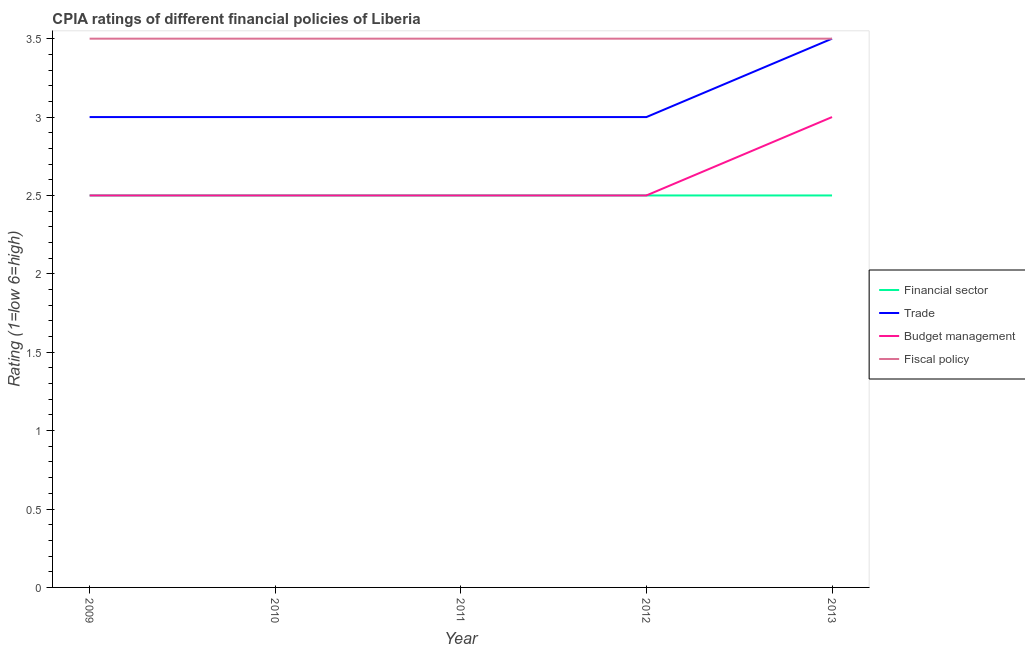What is the cpia rating of fiscal policy in 2011?
Make the answer very short. 3.5. In which year was the cpia rating of fiscal policy maximum?
Your answer should be very brief. 2009. In which year was the cpia rating of fiscal policy minimum?
Your answer should be compact. 2009. What is the difference between the cpia rating of fiscal policy in 2010 and that in 2013?
Your answer should be compact. 0. What is the difference between the cpia rating of financial sector in 2011 and the cpia rating of fiscal policy in 2012?
Give a very brief answer. -1. What is the average cpia rating of budget management per year?
Make the answer very short. 2.6. In the year 2009, what is the difference between the cpia rating of budget management and cpia rating of financial sector?
Ensure brevity in your answer.  0. What is the difference between the highest and the lowest cpia rating of fiscal policy?
Make the answer very short. 0. Is it the case that in every year, the sum of the cpia rating of trade and cpia rating of budget management is greater than the sum of cpia rating of financial sector and cpia rating of fiscal policy?
Keep it short and to the point. No. Is it the case that in every year, the sum of the cpia rating of financial sector and cpia rating of trade is greater than the cpia rating of budget management?
Your response must be concise. Yes. Is the cpia rating of fiscal policy strictly greater than the cpia rating of budget management over the years?
Your response must be concise. Yes. Is the cpia rating of budget management strictly less than the cpia rating of financial sector over the years?
Give a very brief answer. No. How many lines are there?
Offer a terse response. 4. What is the difference between two consecutive major ticks on the Y-axis?
Give a very brief answer. 0.5. Does the graph contain any zero values?
Your answer should be very brief. No. Does the graph contain grids?
Provide a succinct answer. No. Where does the legend appear in the graph?
Give a very brief answer. Center right. What is the title of the graph?
Offer a very short reply. CPIA ratings of different financial policies of Liberia. Does "Rule based governance" appear as one of the legend labels in the graph?
Provide a succinct answer. No. What is the label or title of the X-axis?
Your answer should be very brief. Year. What is the Rating (1=low 6=high) in Financial sector in 2011?
Make the answer very short. 2.5. What is the Rating (1=low 6=high) of Trade in 2011?
Your answer should be compact. 3. What is the Rating (1=low 6=high) of Budget management in 2011?
Offer a terse response. 2.5. What is the Rating (1=low 6=high) in Fiscal policy in 2012?
Provide a short and direct response. 3.5. What is the Rating (1=low 6=high) of Trade in 2013?
Provide a succinct answer. 3.5. Across all years, what is the maximum Rating (1=low 6=high) of Financial sector?
Your response must be concise. 2.5. Across all years, what is the maximum Rating (1=low 6=high) in Fiscal policy?
Keep it short and to the point. 3.5. Across all years, what is the minimum Rating (1=low 6=high) in Budget management?
Your response must be concise. 2.5. Across all years, what is the minimum Rating (1=low 6=high) in Fiscal policy?
Keep it short and to the point. 3.5. What is the total Rating (1=low 6=high) of Financial sector in the graph?
Offer a very short reply. 12.5. What is the total Rating (1=low 6=high) of Trade in the graph?
Make the answer very short. 15.5. What is the difference between the Rating (1=low 6=high) of Financial sector in 2009 and that in 2010?
Offer a terse response. 0. What is the difference between the Rating (1=low 6=high) in Trade in 2009 and that in 2010?
Ensure brevity in your answer.  0. What is the difference between the Rating (1=low 6=high) in Budget management in 2009 and that in 2010?
Your response must be concise. 0. What is the difference between the Rating (1=low 6=high) in Financial sector in 2009 and that in 2011?
Provide a short and direct response. 0. What is the difference between the Rating (1=low 6=high) in Trade in 2009 and that in 2011?
Your response must be concise. 0. What is the difference between the Rating (1=low 6=high) of Trade in 2009 and that in 2013?
Keep it short and to the point. -0.5. What is the difference between the Rating (1=low 6=high) in Budget management in 2009 and that in 2013?
Ensure brevity in your answer.  -0.5. What is the difference between the Rating (1=low 6=high) of Trade in 2010 and that in 2011?
Ensure brevity in your answer.  0. What is the difference between the Rating (1=low 6=high) in Budget management in 2010 and that in 2011?
Give a very brief answer. 0. What is the difference between the Rating (1=low 6=high) in Trade in 2010 and that in 2012?
Provide a succinct answer. 0. What is the difference between the Rating (1=low 6=high) of Financial sector in 2010 and that in 2013?
Provide a succinct answer. 0. What is the difference between the Rating (1=low 6=high) in Budget management in 2010 and that in 2013?
Keep it short and to the point. -0.5. What is the difference between the Rating (1=low 6=high) of Financial sector in 2011 and that in 2012?
Ensure brevity in your answer.  0. What is the difference between the Rating (1=low 6=high) in Fiscal policy in 2011 and that in 2012?
Your answer should be very brief. 0. What is the difference between the Rating (1=low 6=high) in Financial sector in 2011 and that in 2013?
Your response must be concise. 0. What is the difference between the Rating (1=low 6=high) of Trade in 2011 and that in 2013?
Your answer should be very brief. -0.5. What is the difference between the Rating (1=low 6=high) in Budget management in 2011 and that in 2013?
Ensure brevity in your answer.  -0.5. What is the difference between the Rating (1=low 6=high) of Fiscal policy in 2011 and that in 2013?
Your answer should be compact. 0. What is the difference between the Rating (1=low 6=high) of Trade in 2012 and that in 2013?
Offer a terse response. -0.5. What is the difference between the Rating (1=low 6=high) of Fiscal policy in 2012 and that in 2013?
Give a very brief answer. 0. What is the difference between the Rating (1=low 6=high) of Financial sector in 2009 and the Rating (1=low 6=high) of Trade in 2010?
Offer a terse response. -0.5. What is the difference between the Rating (1=low 6=high) of Financial sector in 2009 and the Rating (1=low 6=high) of Fiscal policy in 2010?
Offer a very short reply. -1. What is the difference between the Rating (1=low 6=high) of Trade in 2009 and the Rating (1=low 6=high) of Budget management in 2010?
Your answer should be very brief. 0.5. What is the difference between the Rating (1=low 6=high) in Trade in 2009 and the Rating (1=low 6=high) in Fiscal policy in 2010?
Your answer should be compact. -0.5. What is the difference between the Rating (1=low 6=high) in Financial sector in 2009 and the Rating (1=low 6=high) in Budget management in 2011?
Your response must be concise. 0. What is the difference between the Rating (1=low 6=high) of Trade in 2009 and the Rating (1=low 6=high) of Budget management in 2011?
Your answer should be very brief. 0.5. What is the difference between the Rating (1=low 6=high) in Trade in 2009 and the Rating (1=low 6=high) in Fiscal policy in 2011?
Give a very brief answer. -0.5. What is the difference between the Rating (1=low 6=high) in Financial sector in 2009 and the Rating (1=low 6=high) in Trade in 2012?
Keep it short and to the point. -0.5. What is the difference between the Rating (1=low 6=high) of Financial sector in 2009 and the Rating (1=low 6=high) of Fiscal policy in 2012?
Offer a very short reply. -1. What is the difference between the Rating (1=low 6=high) in Trade in 2009 and the Rating (1=low 6=high) in Budget management in 2012?
Keep it short and to the point. 0.5. What is the difference between the Rating (1=low 6=high) in Trade in 2009 and the Rating (1=low 6=high) in Fiscal policy in 2012?
Your response must be concise. -0.5. What is the difference between the Rating (1=low 6=high) in Financial sector in 2009 and the Rating (1=low 6=high) in Trade in 2013?
Offer a very short reply. -1. What is the difference between the Rating (1=low 6=high) in Trade in 2009 and the Rating (1=low 6=high) in Budget management in 2013?
Your answer should be compact. 0. What is the difference between the Rating (1=low 6=high) in Budget management in 2009 and the Rating (1=low 6=high) in Fiscal policy in 2013?
Give a very brief answer. -1. What is the difference between the Rating (1=low 6=high) in Financial sector in 2010 and the Rating (1=low 6=high) in Trade in 2011?
Ensure brevity in your answer.  -0.5. What is the difference between the Rating (1=low 6=high) in Financial sector in 2010 and the Rating (1=low 6=high) in Fiscal policy in 2011?
Your answer should be compact. -1. What is the difference between the Rating (1=low 6=high) in Trade in 2010 and the Rating (1=low 6=high) in Budget management in 2011?
Provide a succinct answer. 0.5. What is the difference between the Rating (1=low 6=high) of Financial sector in 2010 and the Rating (1=low 6=high) of Trade in 2012?
Give a very brief answer. -0.5. What is the difference between the Rating (1=low 6=high) of Financial sector in 2010 and the Rating (1=low 6=high) of Trade in 2013?
Provide a succinct answer. -1. What is the difference between the Rating (1=low 6=high) of Financial sector in 2010 and the Rating (1=low 6=high) of Budget management in 2013?
Your answer should be very brief. -0.5. What is the difference between the Rating (1=low 6=high) in Financial sector in 2010 and the Rating (1=low 6=high) in Fiscal policy in 2013?
Give a very brief answer. -1. What is the difference between the Rating (1=low 6=high) of Trade in 2010 and the Rating (1=low 6=high) of Budget management in 2013?
Keep it short and to the point. 0. What is the difference between the Rating (1=low 6=high) in Financial sector in 2011 and the Rating (1=low 6=high) in Trade in 2012?
Provide a succinct answer. -0.5. What is the difference between the Rating (1=low 6=high) in Financial sector in 2011 and the Rating (1=low 6=high) in Fiscal policy in 2012?
Offer a very short reply. -1. What is the difference between the Rating (1=low 6=high) of Trade in 2011 and the Rating (1=low 6=high) of Budget management in 2012?
Your answer should be very brief. 0.5. What is the difference between the Rating (1=low 6=high) of Budget management in 2011 and the Rating (1=low 6=high) of Fiscal policy in 2012?
Your answer should be compact. -1. What is the difference between the Rating (1=low 6=high) of Financial sector in 2011 and the Rating (1=low 6=high) of Trade in 2013?
Ensure brevity in your answer.  -1. What is the difference between the Rating (1=low 6=high) in Trade in 2011 and the Rating (1=low 6=high) in Fiscal policy in 2013?
Ensure brevity in your answer.  -0.5. What is the difference between the Rating (1=low 6=high) in Budget management in 2011 and the Rating (1=low 6=high) in Fiscal policy in 2013?
Ensure brevity in your answer.  -1. What is the difference between the Rating (1=low 6=high) of Financial sector in 2012 and the Rating (1=low 6=high) of Trade in 2013?
Provide a succinct answer. -1. What is the difference between the Rating (1=low 6=high) in Financial sector in 2012 and the Rating (1=low 6=high) in Budget management in 2013?
Provide a short and direct response. -0.5. What is the difference between the Rating (1=low 6=high) in Trade in 2012 and the Rating (1=low 6=high) in Fiscal policy in 2013?
Provide a succinct answer. -0.5. What is the difference between the Rating (1=low 6=high) in Budget management in 2012 and the Rating (1=low 6=high) in Fiscal policy in 2013?
Ensure brevity in your answer.  -1. What is the average Rating (1=low 6=high) of Financial sector per year?
Offer a terse response. 2.5. What is the average Rating (1=low 6=high) of Trade per year?
Provide a short and direct response. 3.1. What is the average Rating (1=low 6=high) of Budget management per year?
Give a very brief answer. 2.6. In the year 2009, what is the difference between the Rating (1=low 6=high) of Financial sector and Rating (1=low 6=high) of Trade?
Offer a very short reply. -0.5. In the year 2009, what is the difference between the Rating (1=low 6=high) of Financial sector and Rating (1=low 6=high) of Fiscal policy?
Your answer should be compact. -1. In the year 2009, what is the difference between the Rating (1=low 6=high) of Trade and Rating (1=low 6=high) of Fiscal policy?
Your answer should be very brief. -0.5. In the year 2010, what is the difference between the Rating (1=low 6=high) of Financial sector and Rating (1=low 6=high) of Trade?
Your answer should be compact. -0.5. In the year 2010, what is the difference between the Rating (1=low 6=high) in Financial sector and Rating (1=low 6=high) in Budget management?
Your answer should be compact. 0. In the year 2011, what is the difference between the Rating (1=low 6=high) in Financial sector and Rating (1=low 6=high) in Trade?
Ensure brevity in your answer.  -0.5. In the year 2011, what is the difference between the Rating (1=low 6=high) of Financial sector and Rating (1=low 6=high) of Budget management?
Offer a terse response. 0. In the year 2012, what is the difference between the Rating (1=low 6=high) of Financial sector and Rating (1=low 6=high) of Budget management?
Keep it short and to the point. 0. In the year 2012, what is the difference between the Rating (1=low 6=high) in Trade and Rating (1=low 6=high) in Budget management?
Offer a very short reply. 0.5. In the year 2013, what is the difference between the Rating (1=low 6=high) in Financial sector and Rating (1=low 6=high) in Budget management?
Your response must be concise. -0.5. In the year 2013, what is the difference between the Rating (1=low 6=high) of Trade and Rating (1=low 6=high) of Budget management?
Keep it short and to the point. 0.5. What is the ratio of the Rating (1=low 6=high) in Trade in 2009 to that in 2010?
Your response must be concise. 1. What is the ratio of the Rating (1=low 6=high) in Budget management in 2009 to that in 2010?
Make the answer very short. 1. What is the ratio of the Rating (1=low 6=high) of Budget management in 2009 to that in 2011?
Make the answer very short. 1. What is the ratio of the Rating (1=low 6=high) of Fiscal policy in 2009 to that in 2011?
Keep it short and to the point. 1. What is the ratio of the Rating (1=low 6=high) of Trade in 2009 to that in 2012?
Your answer should be compact. 1. What is the ratio of the Rating (1=low 6=high) of Budget management in 2009 to that in 2012?
Provide a succinct answer. 1. What is the ratio of the Rating (1=low 6=high) in Trade in 2009 to that in 2013?
Keep it short and to the point. 0.86. What is the ratio of the Rating (1=low 6=high) in Budget management in 2009 to that in 2013?
Keep it short and to the point. 0.83. What is the ratio of the Rating (1=low 6=high) in Fiscal policy in 2009 to that in 2013?
Ensure brevity in your answer.  1. What is the ratio of the Rating (1=low 6=high) of Financial sector in 2010 to that in 2011?
Your response must be concise. 1. What is the ratio of the Rating (1=low 6=high) in Fiscal policy in 2010 to that in 2011?
Your answer should be compact. 1. What is the ratio of the Rating (1=low 6=high) of Financial sector in 2010 to that in 2012?
Your answer should be very brief. 1. What is the ratio of the Rating (1=low 6=high) in Financial sector in 2010 to that in 2013?
Keep it short and to the point. 1. What is the ratio of the Rating (1=low 6=high) of Trade in 2010 to that in 2013?
Make the answer very short. 0.86. What is the ratio of the Rating (1=low 6=high) of Budget management in 2010 to that in 2013?
Provide a succinct answer. 0.83. What is the ratio of the Rating (1=low 6=high) in Trade in 2011 to that in 2012?
Provide a short and direct response. 1. What is the ratio of the Rating (1=low 6=high) of Budget management in 2011 to that in 2012?
Your answer should be compact. 1. What is the ratio of the Rating (1=low 6=high) of Fiscal policy in 2011 to that in 2012?
Keep it short and to the point. 1. What is the ratio of the Rating (1=low 6=high) in Trade in 2011 to that in 2013?
Make the answer very short. 0.86. What is the ratio of the Rating (1=low 6=high) of Fiscal policy in 2011 to that in 2013?
Provide a succinct answer. 1. What is the ratio of the Rating (1=low 6=high) of Trade in 2012 to that in 2013?
Your answer should be very brief. 0.86. What is the ratio of the Rating (1=low 6=high) in Fiscal policy in 2012 to that in 2013?
Offer a terse response. 1. What is the difference between the highest and the second highest Rating (1=low 6=high) in Trade?
Make the answer very short. 0.5. What is the difference between the highest and the second highest Rating (1=low 6=high) of Budget management?
Ensure brevity in your answer.  0.5. What is the difference between the highest and the second highest Rating (1=low 6=high) of Fiscal policy?
Ensure brevity in your answer.  0. What is the difference between the highest and the lowest Rating (1=low 6=high) in Trade?
Keep it short and to the point. 0.5. What is the difference between the highest and the lowest Rating (1=low 6=high) in Budget management?
Keep it short and to the point. 0.5. What is the difference between the highest and the lowest Rating (1=low 6=high) in Fiscal policy?
Keep it short and to the point. 0. 